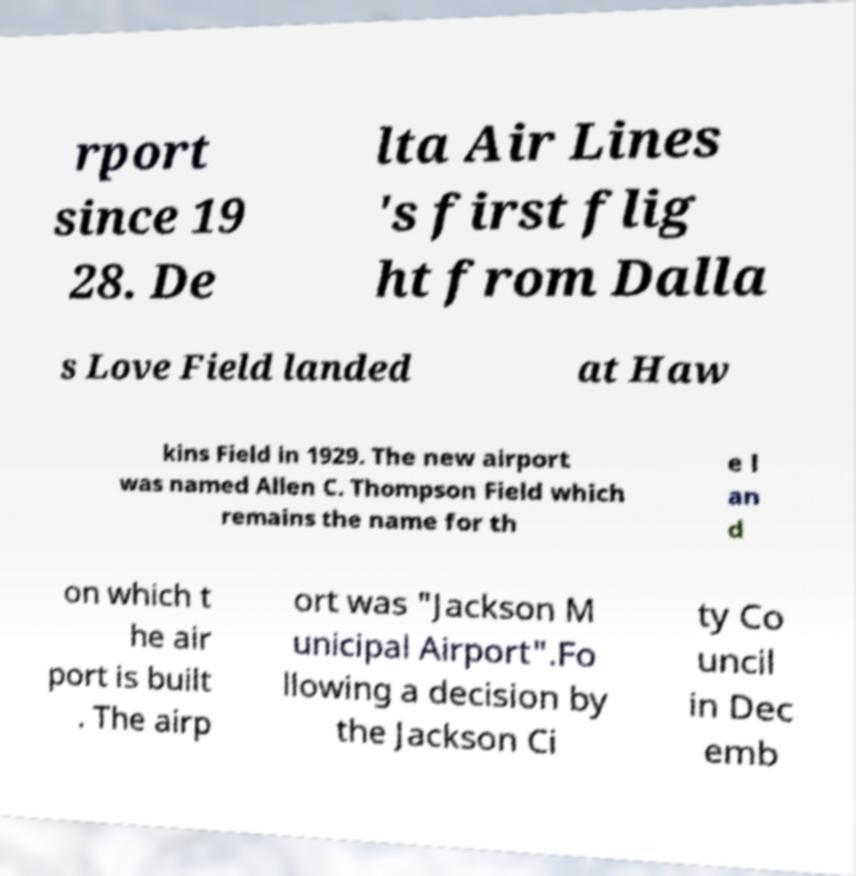Can you accurately transcribe the text from the provided image for me? rport since 19 28. De lta Air Lines 's first flig ht from Dalla s Love Field landed at Haw kins Field in 1929. The new airport was named Allen C. Thompson Field which remains the name for th e l an d on which t he air port is built . The airp ort was "Jackson M unicipal Airport".Fo llowing a decision by the Jackson Ci ty Co uncil in Dec emb 